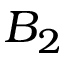Convert formula to latex. <formula><loc_0><loc_0><loc_500><loc_500>B _ { 2 }</formula> 